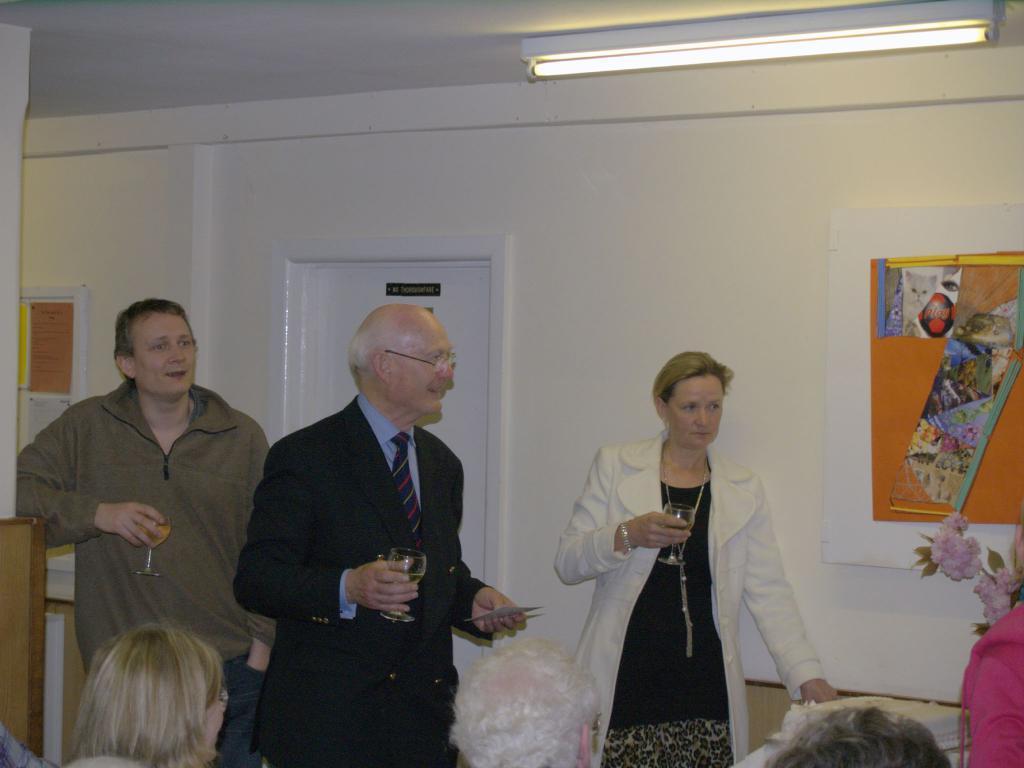In one or two sentences, can you explain what this image depicts? This picture describe about the inside view of the room. In front we can see old man wearing a black coat holding wine glass in the hand. Beside we can see women wearing white coat and holding a glass in the hand. Behind we can see a man wearing brown t- shirt holding the wine glass in the hand. In the background we can see white color wall and white door. 